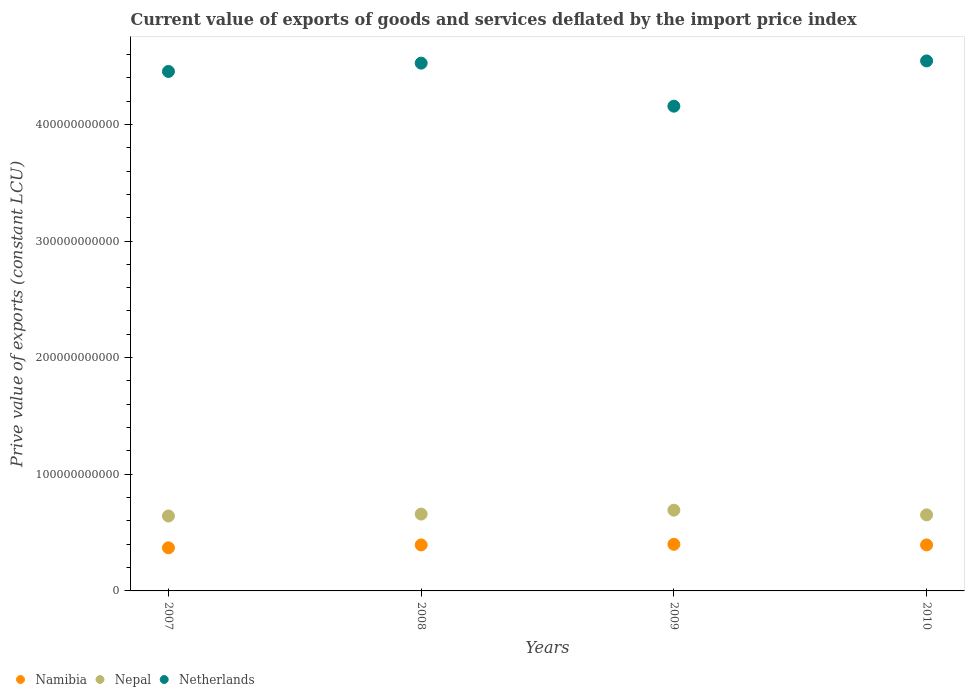How many different coloured dotlines are there?
Offer a terse response. 3. Is the number of dotlines equal to the number of legend labels?
Provide a short and direct response. Yes. What is the prive value of exports in Nepal in 2010?
Offer a very short reply. 6.52e+1. Across all years, what is the maximum prive value of exports in Nepal?
Keep it short and to the point. 6.92e+1. Across all years, what is the minimum prive value of exports in Nepal?
Make the answer very short. 6.42e+1. In which year was the prive value of exports in Netherlands maximum?
Your answer should be compact. 2010. What is the total prive value of exports in Nepal in the graph?
Give a very brief answer. 2.65e+11. What is the difference between the prive value of exports in Nepal in 2007 and that in 2008?
Your response must be concise. -1.64e+09. What is the difference between the prive value of exports in Nepal in 2009 and the prive value of exports in Namibia in 2010?
Your answer should be compact. 2.98e+1. What is the average prive value of exports in Namibia per year?
Provide a succinct answer. 3.89e+1. In the year 2007, what is the difference between the prive value of exports in Namibia and prive value of exports in Netherlands?
Your answer should be very brief. -4.08e+11. In how many years, is the prive value of exports in Namibia greater than 260000000000 LCU?
Give a very brief answer. 0. What is the ratio of the prive value of exports in Namibia in 2007 to that in 2008?
Give a very brief answer. 0.94. Is the prive value of exports in Nepal in 2007 less than that in 2010?
Keep it short and to the point. Yes. Is the difference between the prive value of exports in Namibia in 2007 and 2008 greater than the difference between the prive value of exports in Netherlands in 2007 and 2008?
Provide a succinct answer. Yes. What is the difference between the highest and the second highest prive value of exports in Nepal?
Provide a succinct answer. 3.34e+09. What is the difference between the highest and the lowest prive value of exports in Nepal?
Make the answer very short. 4.98e+09. In how many years, is the prive value of exports in Namibia greater than the average prive value of exports in Namibia taken over all years?
Offer a very short reply. 3. Is the sum of the prive value of exports in Namibia in 2008 and 2009 greater than the maximum prive value of exports in Netherlands across all years?
Provide a short and direct response. No. Does the prive value of exports in Nepal monotonically increase over the years?
Your answer should be very brief. No. Is the prive value of exports in Nepal strictly less than the prive value of exports in Namibia over the years?
Provide a succinct answer. No. How many dotlines are there?
Give a very brief answer. 3. What is the difference between two consecutive major ticks on the Y-axis?
Your answer should be compact. 1.00e+11. Does the graph contain any zero values?
Give a very brief answer. No. What is the title of the graph?
Provide a succinct answer. Current value of exports of goods and services deflated by the import price index. What is the label or title of the Y-axis?
Ensure brevity in your answer.  Prive value of exports (constant LCU). What is the Prive value of exports (constant LCU) in Namibia in 2007?
Offer a very short reply. 3.70e+1. What is the Prive value of exports (constant LCU) of Nepal in 2007?
Your answer should be compact. 6.42e+1. What is the Prive value of exports (constant LCU) in Netherlands in 2007?
Give a very brief answer. 4.45e+11. What is the Prive value of exports (constant LCU) in Namibia in 2008?
Your response must be concise. 3.94e+1. What is the Prive value of exports (constant LCU) of Nepal in 2008?
Keep it short and to the point. 6.59e+1. What is the Prive value of exports (constant LCU) in Netherlands in 2008?
Your response must be concise. 4.52e+11. What is the Prive value of exports (constant LCU) of Namibia in 2009?
Ensure brevity in your answer.  4.00e+1. What is the Prive value of exports (constant LCU) of Nepal in 2009?
Your answer should be compact. 6.92e+1. What is the Prive value of exports (constant LCU) of Netherlands in 2009?
Make the answer very short. 4.16e+11. What is the Prive value of exports (constant LCU) of Namibia in 2010?
Your response must be concise. 3.94e+1. What is the Prive value of exports (constant LCU) in Nepal in 2010?
Offer a very short reply. 6.52e+1. What is the Prive value of exports (constant LCU) of Netherlands in 2010?
Keep it short and to the point. 4.54e+11. Across all years, what is the maximum Prive value of exports (constant LCU) in Namibia?
Offer a terse response. 4.00e+1. Across all years, what is the maximum Prive value of exports (constant LCU) in Nepal?
Give a very brief answer. 6.92e+1. Across all years, what is the maximum Prive value of exports (constant LCU) of Netherlands?
Make the answer very short. 4.54e+11. Across all years, what is the minimum Prive value of exports (constant LCU) in Namibia?
Offer a terse response. 3.70e+1. Across all years, what is the minimum Prive value of exports (constant LCU) in Nepal?
Your answer should be compact. 6.42e+1. Across all years, what is the minimum Prive value of exports (constant LCU) of Netherlands?
Your answer should be compact. 4.16e+11. What is the total Prive value of exports (constant LCU) of Namibia in the graph?
Give a very brief answer. 1.56e+11. What is the total Prive value of exports (constant LCU) of Nepal in the graph?
Keep it short and to the point. 2.65e+11. What is the total Prive value of exports (constant LCU) of Netherlands in the graph?
Your response must be concise. 1.77e+12. What is the difference between the Prive value of exports (constant LCU) of Namibia in 2007 and that in 2008?
Offer a terse response. -2.47e+09. What is the difference between the Prive value of exports (constant LCU) of Nepal in 2007 and that in 2008?
Your response must be concise. -1.64e+09. What is the difference between the Prive value of exports (constant LCU) of Netherlands in 2007 and that in 2008?
Keep it short and to the point. -7.11e+09. What is the difference between the Prive value of exports (constant LCU) of Namibia in 2007 and that in 2009?
Keep it short and to the point. -3.00e+09. What is the difference between the Prive value of exports (constant LCU) in Nepal in 2007 and that in 2009?
Ensure brevity in your answer.  -4.98e+09. What is the difference between the Prive value of exports (constant LCU) in Netherlands in 2007 and that in 2009?
Provide a succinct answer. 2.98e+1. What is the difference between the Prive value of exports (constant LCU) in Namibia in 2007 and that in 2010?
Provide a short and direct response. -2.49e+09. What is the difference between the Prive value of exports (constant LCU) in Nepal in 2007 and that in 2010?
Provide a succinct answer. -9.81e+08. What is the difference between the Prive value of exports (constant LCU) of Netherlands in 2007 and that in 2010?
Your response must be concise. -9.02e+09. What is the difference between the Prive value of exports (constant LCU) in Namibia in 2008 and that in 2009?
Your response must be concise. -5.32e+08. What is the difference between the Prive value of exports (constant LCU) of Nepal in 2008 and that in 2009?
Provide a short and direct response. -3.34e+09. What is the difference between the Prive value of exports (constant LCU) in Netherlands in 2008 and that in 2009?
Your answer should be compact. 3.69e+1. What is the difference between the Prive value of exports (constant LCU) in Namibia in 2008 and that in 2010?
Ensure brevity in your answer.  -2.25e+07. What is the difference between the Prive value of exports (constant LCU) in Nepal in 2008 and that in 2010?
Ensure brevity in your answer.  6.59e+08. What is the difference between the Prive value of exports (constant LCU) of Netherlands in 2008 and that in 2010?
Your response must be concise. -1.91e+09. What is the difference between the Prive value of exports (constant LCU) of Namibia in 2009 and that in 2010?
Provide a succinct answer. 5.09e+08. What is the difference between the Prive value of exports (constant LCU) in Nepal in 2009 and that in 2010?
Make the answer very short. 4.00e+09. What is the difference between the Prive value of exports (constant LCU) in Netherlands in 2009 and that in 2010?
Give a very brief answer. -3.88e+1. What is the difference between the Prive value of exports (constant LCU) of Namibia in 2007 and the Prive value of exports (constant LCU) of Nepal in 2008?
Offer a very short reply. -2.89e+1. What is the difference between the Prive value of exports (constant LCU) of Namibia in 2007 and the Prive value of exports (constant LCU) of Netherlands in 2008?
Ensure brevity in your answer.  -4.16e+11. What is the difference between the Prive value of exports (constant LCU) in Nepal in 2007 and the Prive value of exports (constant LCU) in Netherlands in 2008?
Offer a very short reply. -3.88e+11. What is the difference between the Prive value of exports (constant LCU) of Namibia in 2007 and the Prive value of exports (constant LCU) of Nepal in 2009?
Keep it short and to the point. -3.23e+1. What is the difference between the Prive value of exports (constant LCU) in Namibia in 2007 and the Prive value of exports (constant LCU) in Netherlands in 2009?
Make the answer very short. -3.79e+11. What is the difference between the Prive value of exports (constant LCU) in Nepal in 2007 and the Prive value of exports (constant LCU) in Netherlands in 2009?
Ensure brevity in your answer.  -3.51e+11. What is the difference between the Prive value of exports (constant LCU) in Namibia in 2007 and the Prive value of exports (constant LCU) in Nepal in 2010?
Your answer should be very brief. -2.83e+1. What is the difference between the Prive value of exports (constant LCU) in Namibia in 2007 and the Prive value of exports (constant LCU) in Netherlands in 2010?
Give a very brief answer. -4.17e+11. What is the difference between the Prive value of exports (constant LCU) of Nepal in 2007 and the Prive value of exports (constant LCU) of Netherlands in 2010?
Give a very brief answer. -3.90e+11. What is the difference between the Prive value of exports (constant LCU) of Namibia in 2008 and the Prive value of exports (constant LCU) of Nepal in 2009?
Provide a short and direct response. -2.98e+1. What is the difference between the Prive value of exports (constant LCU) of Namibia in 2008 and the Prive value of exports (constant LCU) of Netherlands in 2009?
Your response must be concise. -3.76e+11. What is the difference between the Prive value of exports (constant LCU) of Nepal in 2008 and the Prive value of exports (constant LCU) of Netherlands in 2009?
Provide a short and direct response. -3.50e+11. What is the difference between the Prive value of exports (constant LCU) of Namibia in 2008 and the Prive value of exports (constant LCU) of Nepal in 2010?
Keep it short and to the point. -2.58e+1. What is the difference between the Prive value of exports (constant LCU) in Namibia in 2008 and the Prive value of exports (constant LCU) in Netherlands in 2010?
Ensure brevity in your answer.  -4.15e+11. What is the difference between the Prive value of exports (constant LCU) of Nepal in 2008 and the Prive value of exports (constant LCU) of Netherlands in 2010?
Offer a terse response. -3.89e+11. What is the difference between the Prive value of exports (constant LCU) of Namibia in 2009 and the Prive value of exports (constant LCU) of Nepal in 2010?
Provide a succinct answer. -2.53e+1. What is the difference between the Prive value of exports (constant LCU) in Namibia in 2009 and the Prive value of exports (constant LCU) in Netherlands in 2010?
Keep it short and to the point. -4.14e+11. What is the difference between the Prive value of exports (constant LCU) of Nepal in 2009 and the Prive value of exports (constant LCU) of Netherlands in 2010?
Make the answer very short. -3.85e+11. What is the average Prive value of exports (constant LCU) of Namibia per year?
Ensure brevity in your answer.  3.89e+1. What is the average Prive value of exports (constant LCU) of Nepal per year?
Give a very brief answer. 6.61e+1. What is the average Prive value of exports (constant LCU) of Netherlands per year?
Provide a short and direct response. 4.42e+11. In the year 2007, what is the difference between the Prive value of exports (constant LCU) of Namibia and Prive value of exports (constant LCU) of Nepal?
Give a very brief answer. -2.73e+1. In the year 2007, what is the difference between the Prive value of exports (constant LCU) in Namibia and Prive value of exports (constant LCU) in Netherlands?
Offer a terse response. -4.08e+11. In the year 2007, what is the difference between the Prive value of exports (constant LCU) in Nepal and Prive value of exports (constant LCU) in Netherlands?
Provide a succinct answer. -3.81e+11. In the year 2008, what is the difference between the Prive value of exports (constant LCU) in Namibia and Prive value of exports (constant LCU) in Nepal?
Make the answer very short. -2.65e+1. In the year 2008, what is the difference between the Prive value of exports (constant LCU) in Namibia and Prive value of exports (constant LCU) in Netherlands?
Your answer should be compact. -4.13e+11. In the year 2008, what is the difference between the Prive value of exports (constant LCU) in Nepal and Prive value of exports (constant LCU) in Netherlands?
Make the answer very short. -3.87e+11. In the year 2009, what is the difference between the Prive value of exports (constant LCU) in Namibia and Prive value of exports (constant LCU) in Nepal?
Offer a terse response. -2.93e+1. In the year 2009, what is the difference between the Prive value of exports (constant LCU) in Namibia and Prive value of exports (constant LCU) in Netherlands?
Your answer should be compact. -3.76e+11. In the year 2009, what is the difference between the Prive value of exports (constant LCU) of Nepal and Prive value of exports (constant LCU) of Netherlands?
Offer a very short reply. -3.46e+11. In the year 2010, what is the difference between the Prive value of exports (constant LCU) in Namibia and Prive value of exports (constant LCU) in Nepal?
Give a very brief answer. -2.58e+1. In the year 2010, what is the difference between the Prive value of exports (constant LCU) of Namibia and Prive value of exports (constant LCU) of Netherlands?
Give a very brief answer. -4.15e+11. In the year 2010, what is the difference between the Prive value of exports (constant LCU) in Nepal and Prive value of exports (constant LCU) in Netherlands?
Offer a very short reply. -3.89e+11. What is the ratio of the Prive value of exports (constant LCU) of Namibia in 2007 to that in 2008?
Keep it short and to the point. 0.94. What is the ratio of the Prive value of exports (constant LCU) of Nepal in 2007 to that in 2008?
Offer a very short reply. 0.98. What is the ratio of the Prive value of exports (constant LCU) in Netherlands in 2007 to that in 2008?
Keep it short and to the point. 0.98. What is the ratio of the Prive value of exports (constant LCU) of Namibia in 2007 to that in 2009?
Offer a very short reply. 0.92. What is the ratio of the Prive value of exports (constant LCU) of Nepal in 2007 to that in 2009?
Provide a short and direct response. 0.93. What is the ratio of the Prive value of exports (constant LCU) in Netherlands in 2007 to that in 2009?
Ensure brevity in your answer.  1.07. What is the ratio of the Prive value of exports (constant LCU) in Namibia in 2007 to that in 2010?
Offer a very short reply. 0.94. What is the ratio of the Prive value of exports (constant LCU) of Netherlands in 2007 to that in 2010?
Offer a terse response. 0.98. What is the ratio of the Prive value of exports (constant LCU) of Namibia in 2008 to that in 2009?
Offer a terse response. 0.99. What is the ratio of the Prive value of exports (constant LCU) in Nepal in 2008 to that in 2009?
Offer a terse response. 0.95. What is the ratio of the Prive value of exports (constant LCU) of Netherlands in 2008 to that in 2009?
Offer a very short reply. 1.09. What is the ratio of the Prive value of exports (constant LCU) in Netherlands in 2008 to that in 2010?
Your answer should be very brief. 1. What is the ratio of the Prive value of exports (constant LCU) in Namibia in 2009 to that in 2010?
Keep it short and to the point. 1.01. What is the ratio of the Prive value of exports (constant LCU) in Nepal in 2009 to that in 2010?
Provide a short and direct response. 1.06. What is the ratio of the Prive value of exports (constant LCU) of Netherlands in 2009 to that in 2010?
Your response must be concise. 0.91. What is the difference between the highest and the second highest Prive value of exports (constant LCU) in Namibia?
Give a very brief answer. 5.09e+08. What is the difference between the highest and the second highest Prive value of exports (constant LCU) in Nepal?
Your response must be concise. 3.34e+09. What is the difference between the highest and the second highest Prive value of exports (constant LCU) of Netherlands?
Offer a very short reply. 1.91e+09. What is the difference between the highest and the lowest Prive value of exports (constant LCU) of Namibia?
Ensure brevity in your answer.  3.00e+09. What is the difference between the highest and the lowest Prive value of exports (constant LCU) of Nepal?
Offer a terse response. 4.98e+09. What is the difference between the highest and the lowest Prive value of exports (constant LCU) of Netherlands?
Provide a short and direct response. 3.88e+1. 